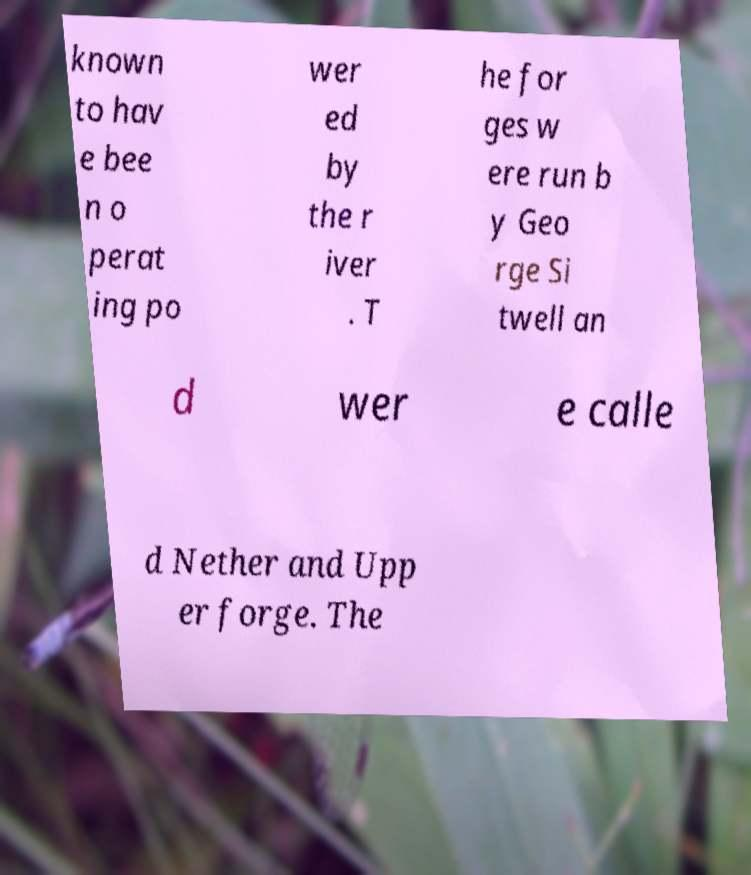Please identify and transcribe the text found in this image. known to hav e bee n o perat ing po wer ed by the r iver . T he for ges w ere run b y Geo rge Si twell an d wer e calle d Nether and Upp er forge. The 